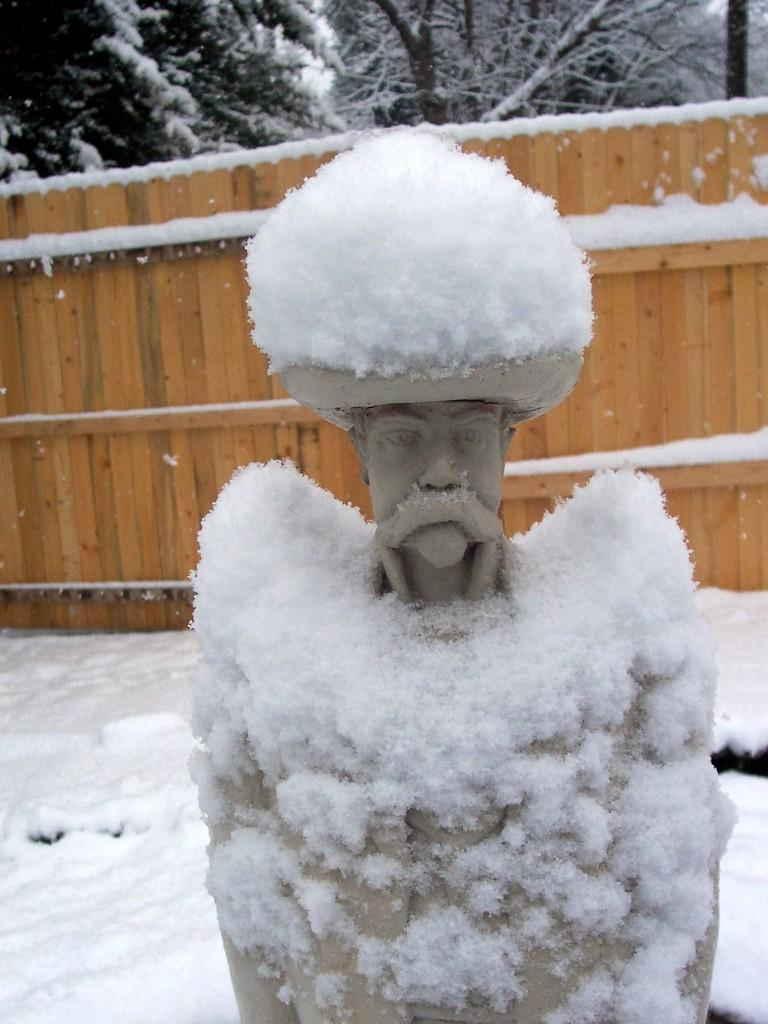What is the main subject in the center of the image? There is a statue in the center of the image. What is located in the middle of the image? There is fencing in the middle of the image. What type of vegetation can be seen at the top of the image? Trees are present at the top of the image. What is the ground condition at the bottom of the image? Snow is visible at the bottom of the image. What type of sheet is covering the statue in the image? There is no sheet covering the statue in the image; it is visible and not obscured. 